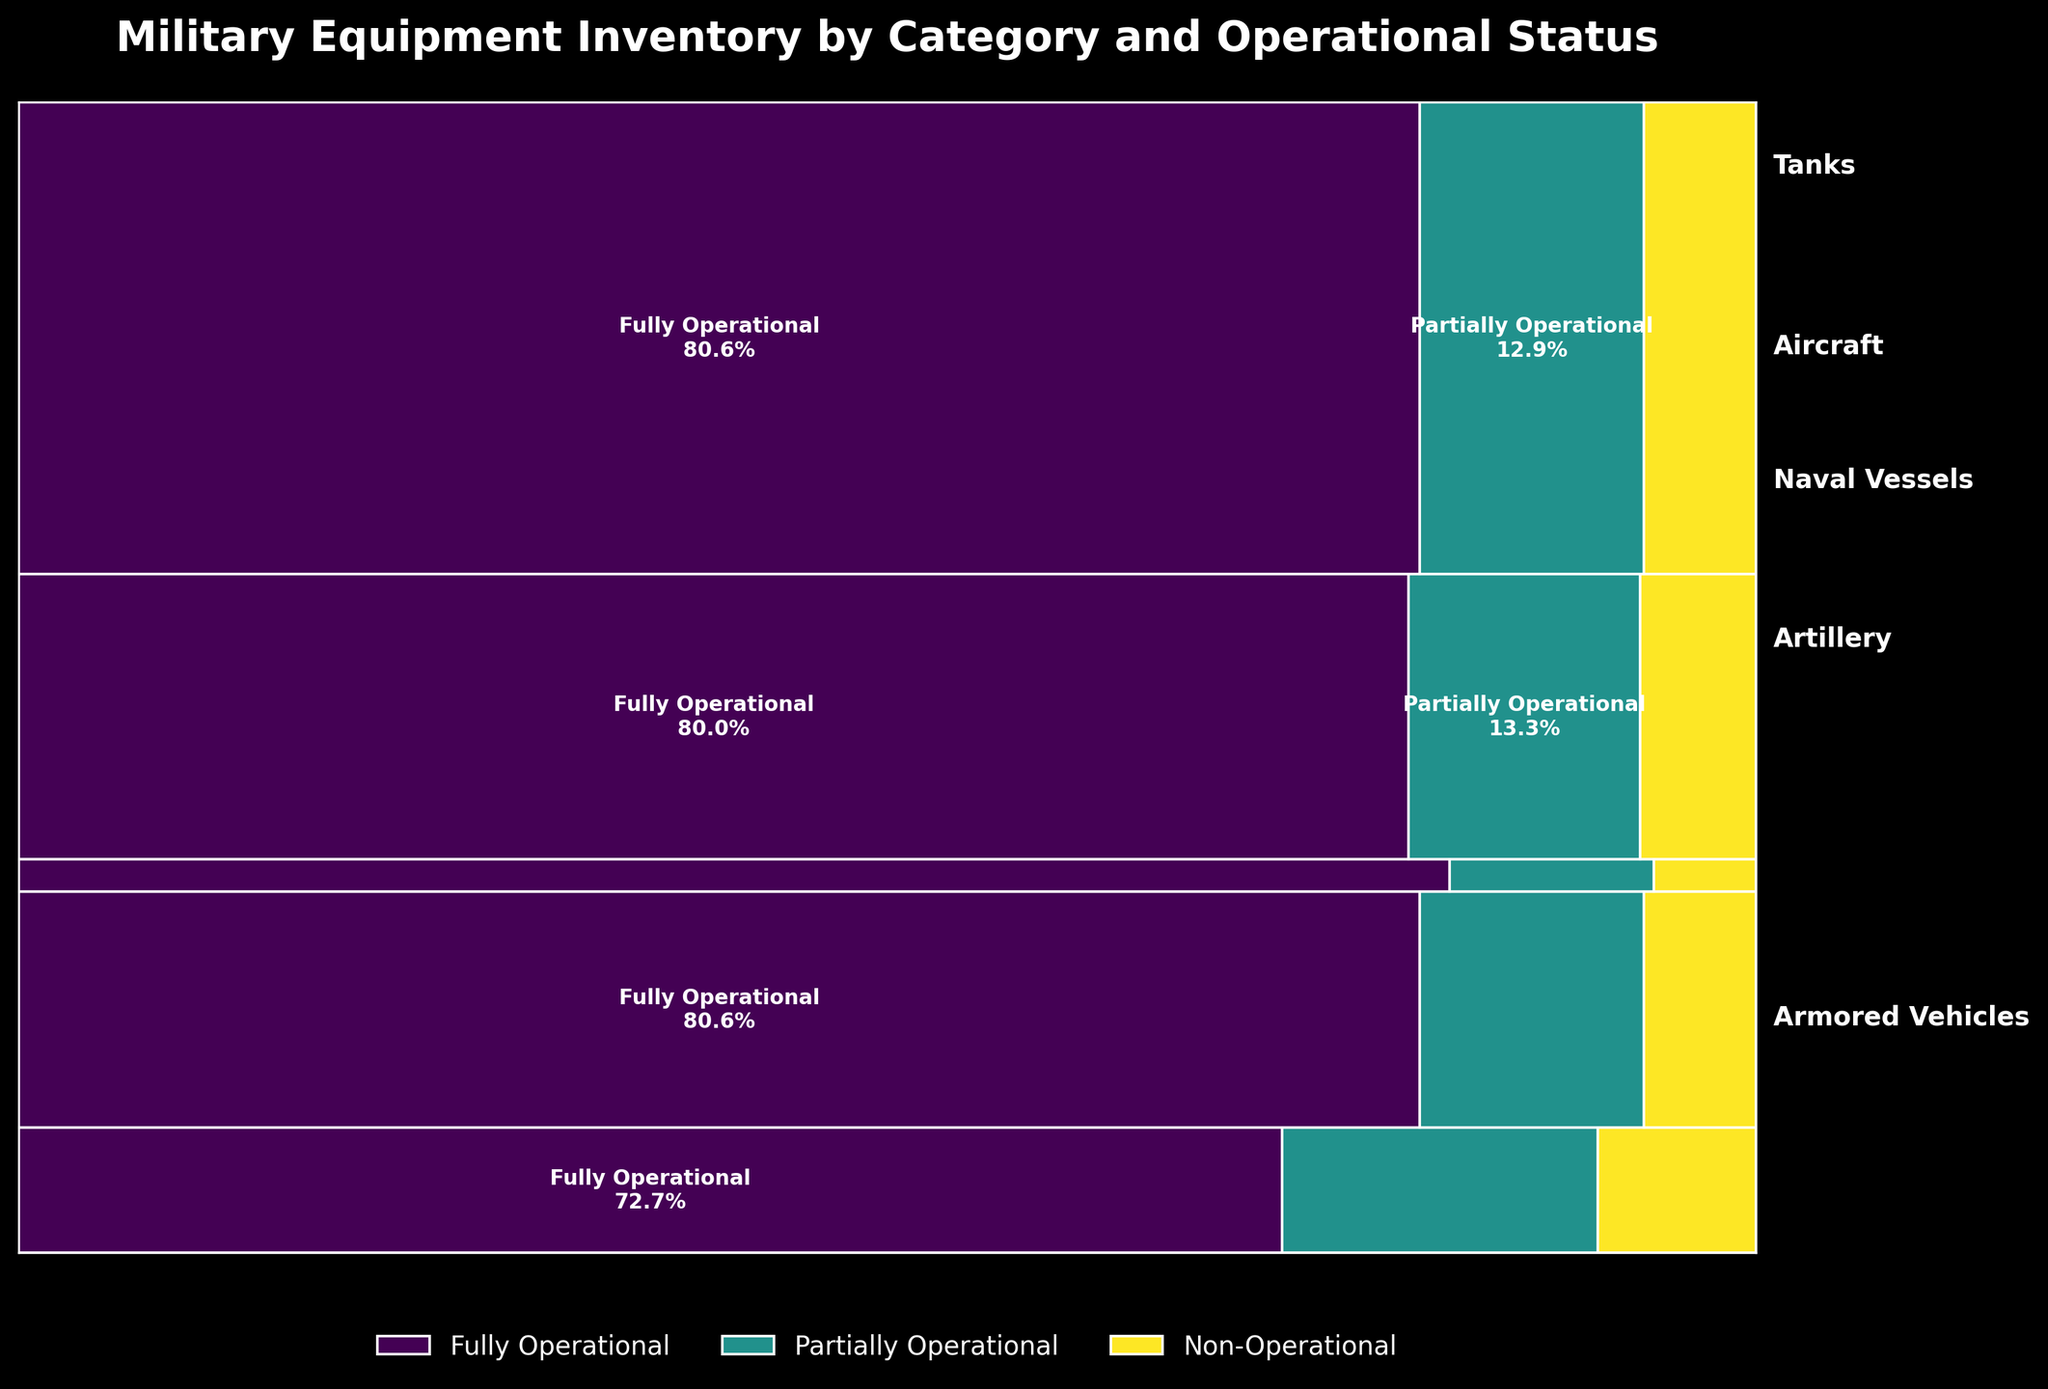What is the title of the plot? The title is prominently displayed at the top of the figure. It usually summarizes the content or purpose of the plot.
Answer: Military Equipment Inventory by Category and Operational Status Which category has the highest count of fully operational equipment? From the plot, we can see that each category has a section and within each section, the fully operational status is marked with a specific color. By identifying the color and checking the largest block, we can see which category has the highest count.
Answer: Armored Vehicles How does the count of non-operational aircraft compare to non-operational artillery? In the mosaic plot, we identify the sections for aircraft and artillery. Then, within each section, we look at the blocks corresponding to the non-operational status to compare their sizes.
Answer: Non-operational artillery is larger What proportion of tanks are partially operational? Locate the tanks section, then find the block representing partially operational status. The proportion is shown within the block, usually as a percentage of the sum of all tanks.
Answer: 15% Which category has the smallest proportion of partially operational equipment? By observing the size of the partially operational sections within each category, we identify the smallest one.
Answer: Naval Vessels What proportion of the total equipment count does artillery represent? First, find the artillery section and note its relative size in the total mosaic plot. It is often displayed as a proportion or percentage of the total.
Answer: 30% Are there more fully operational aircraft or tanks? By comparing the fully operational sections of both aircraft and tanks, we determine which one is larger.
Answer: Aircraft How does the proportion of fully operational armored vehicles compare to partially operational armored vehicles? Observe the armored vehicles section and compare the size of the fully operational block to the partially operational block.
Answer: Fully operational is much larger What is the color used to represent non-operational equipment status? Check the legend and the colors assigned to each operational status. Find the corresponding color of the non-operational status.
Answer: Usually a specific color like red or grey, but can vary Which category has the highest proportion of non-operational equipment? Compare the proportion of non-operational sections within each category's total section.
Answer: Tanks Which operational status within the “Naval Vessels” category has the least proportion? Look at the sections representing "Naval Vessels" and compare the proportions of the fully operational, partially operational, and non-operational blocks.
Answer: Non-Operational 